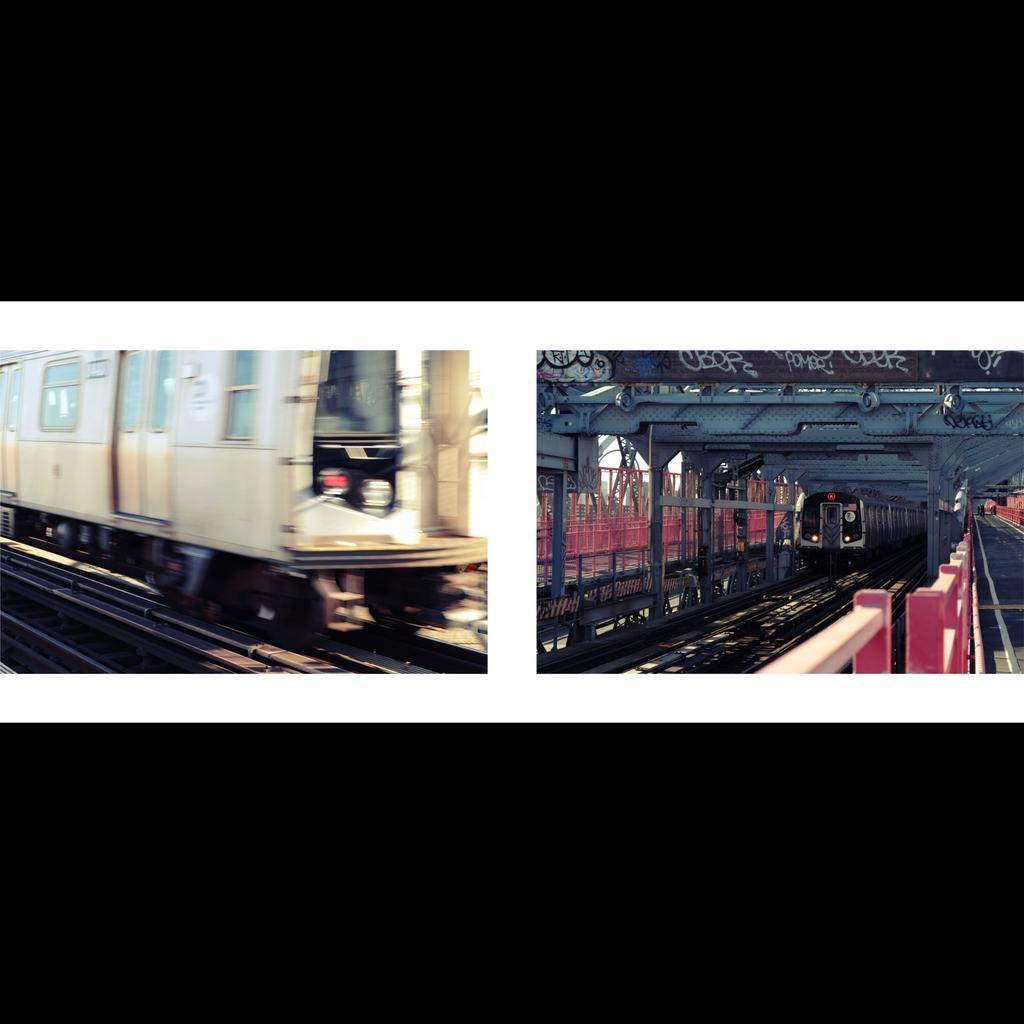Describe this image in one or two sentences. It is a collage picture. On the left side of the image we can see a train on the track. On the right side of the image we can see a train and a few other objects. And we can see the black colored border at the top and bottom of the image. 